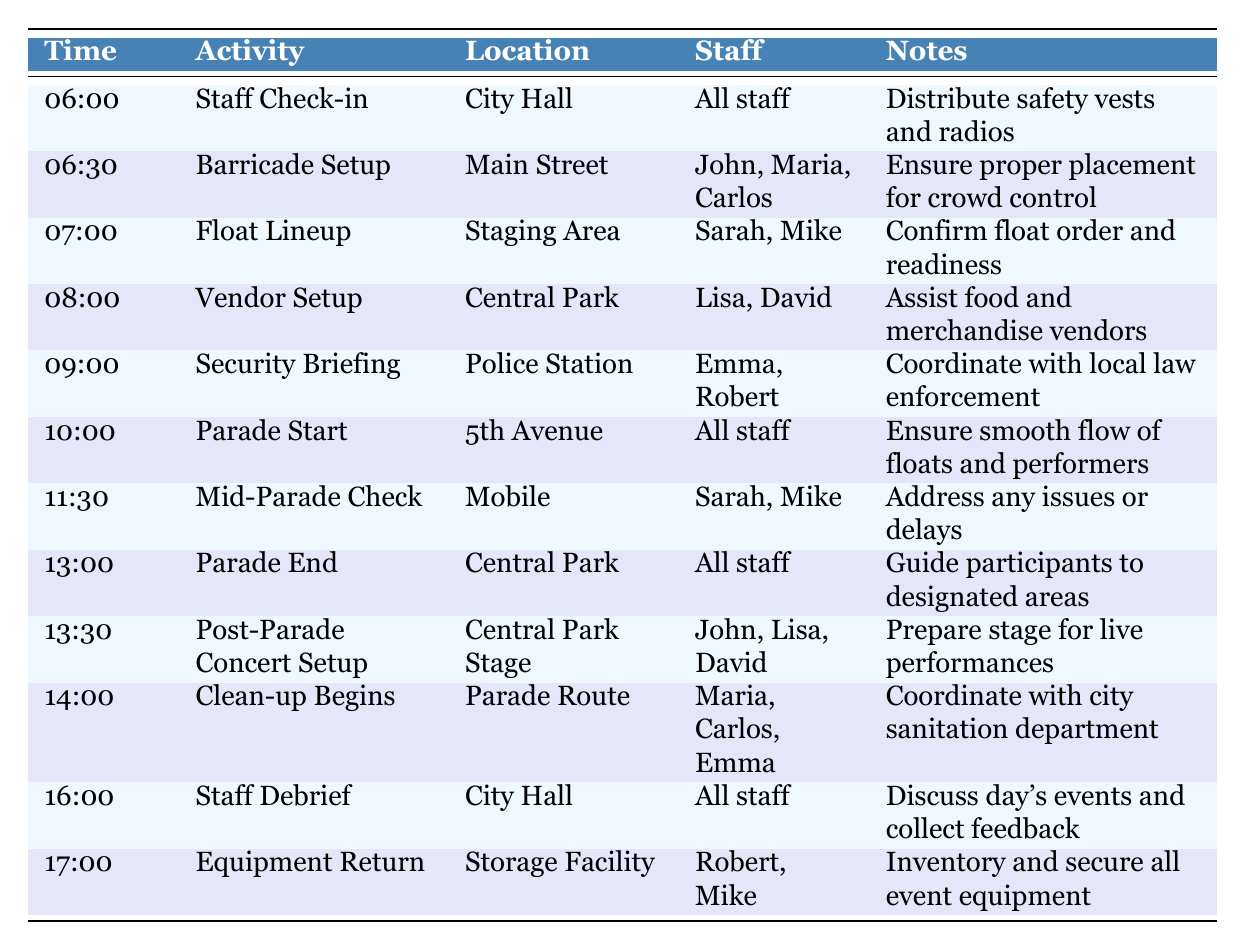What time does the parade start? The table lists the activity "Parade Start" at 10:00. Therefore, this is the time when the parade begins.
Answer: 10:00 Who is responsible for the vendor setup? The table indicates that "Lisa" and "David" are assigned to "Vendor Setup" at "Central Park" at 08:00.
Answer: Lisa and David What is the location for the staff debriefing? According to the table, the "Staff Debrief" is scheduled at "City Hall" at 16:00.
Answer: City Hall How many activities are listed between 08:00 and 13:00? The activities during this time frame are: Vendor Setup, Parade Start, Mid-Parade Check, and Parade End, totalling 4 activities.
Answer: 4 Is there an activity scheduled at 09:30? The table does not list any activity at 09:30, as the next activity after 09:00 is at 10:00.
Answer: No Which staff members are assigned to the Mid-Parade Check? The table shows that "Sarah" and "Mike" are responsible for the "Mid-Parade Check" at "Mobile" at 11:30.
Answer: Sarah and Mike What activity occurs immediately before the Post-Parade Concert Setup? The "Parade End" occurs right before the "Post-Parade Concert Setup" at 13:30.
Answer: Parade End How many staff members are involved in the clean-up? The clean-up involves "Maria," "Carlos," and "Emma," which sums up to 3 staff members.
Answer: 3 At what time do all staff gather for the security briefing? The security briefing is scheduled for 09:00, where specific staff members are noted in the table.
Answer: 09:00 What is the purpose of the Staff Check-in? The notes indicate that the purpose of the Staff Check-in is to distribute safety vests and radios.
Answer: Distribute safety vests and radios Which two staff members handle float lineup? "Sarah" and "Mike" are assigned to confirm float order and readiness for the "Float Lineup" at 07:00.
Answer: Sarah and Mike Are there more activities scheduled before noon than after noon? Before noon, there are 6 activities (06:00 to 12:00) and 5 activities after noon (13:00 onward), which means there are indeed more activities scheduled before noon.
Answer: Yes What is the last activity listed in the schedule? The table lists "Equipment Return" at 17:00 as the final activity for the day.
Answer: Equipment Return How much time elapses between the Parade Start and the Parade End? The Parade Start is at 10:00 and the Parade End is at 13:00, leading to an elapsed time of 3 hours.
Answer: 3 hours List all locations mentioned in the schedule. The locations in the schedule include: City Hall, Main Street, Staging Area, Central Park, Police Station, 5th Avenue, Mobile, Central Park Stage, Parade Route, and Storage Facility.
Answer: City Hall, Main Street, Staging Area, Central Park, Police Station, 5th Avenue, Mobile, Central Park Stage, Parade Route, Storage Facility Who coordinates with the city sanitation department? "Maria," "Carlos," and "Emma" are noted as the staff coordinating with the city sanitation department for the Clean-up activity.
Answer: Maria, Carlos, and Emma 